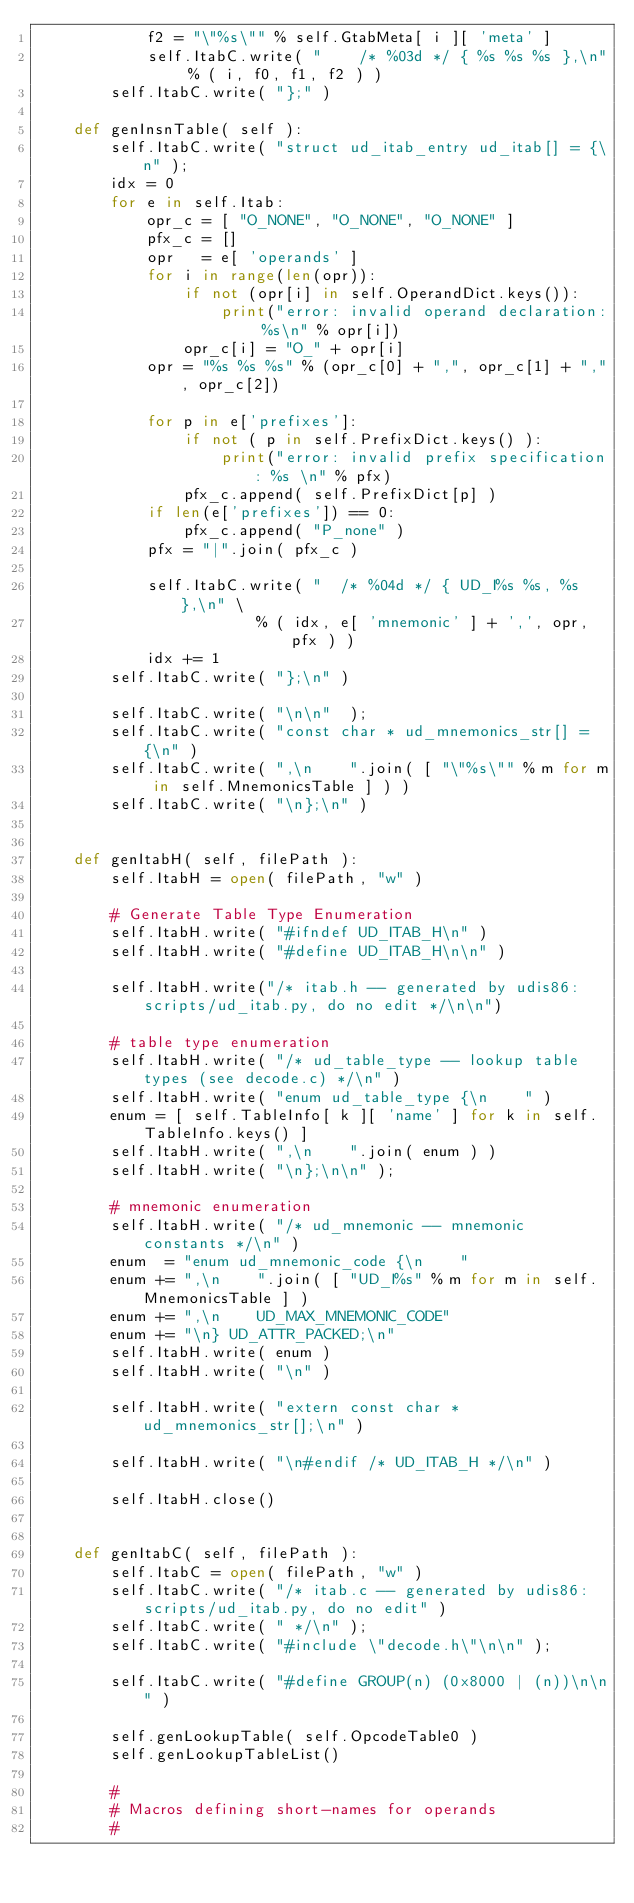<code> <loc_0><loc_0><loc_500><loc_500><_Python_>            f2 = "\"%s\"" % self.GtabMeta[ i ][ 'meta' ]
            self.ItabC.write( "    /* %03d */ { %s %s %s },\n" % ( i, f0, f1, f2 ) )
        self.ItabC.write( "};" )

    def genInsnTable( self ):
        self.ItabC.write( "struct ud_itab_entry ud_itab[] = {\n" );
        idx = 0
        for e in self.Itab:
            opr_c = [ "O_NONE", "O_NONE", "O_NONE" ]
            pfx_c = []
            opr   = e[ 'operands' ]
            for i in range(len(opr)): 
                if not (opr[i] in self.OperandDict.keys()):
                    print("error: invalid operand declaration: %s\n" % opr[i])
                opr_c[i] = "O_" + opr[i]
            opr = "%s %s %s" % (opr_c[0] + ",", opr_c[1] + ",", opr_c[2])

            for p in e['prefixes']:
                if not ( p in self.PrefixDict.keys() ):
                    print("error: invalid prefix specification: %s \n" % pfx)
                pfx_c.append( self.PrefixDict[p] )
            if len(e['prefixes']) == 0:
                pfx_c.append( "P_none" )
            pfx = "|".join( pfx_c )

            self.ItabC.write( "  /* %04d */ { UD_I%s %s, %s },\n" \
                        % ( idx, e[ 'mnemonic' ] + ',', opr, pfx ) )
            idx += 1
        self.ItabC.write( "};\n" )

        self.ItabC.write( "\n\n"  );
        self.ItabC.write( "const char * ud_mnemonics_str[] = {\n" )
        self.ItabC.write( ",\n    ".join( [ "\"%s\"" % m for m in self.MnemonicsTable ] ) )
        self.ItabC.write( "\n};\n" )
 

    def genItabH( self, filePath ):
        self.ItabH = open( filePath, "w" )

        # Generate Table Type Enumeration
        self.ItabH.write( "#ifndef UD_ITAB_H\n" )
        self.ItabH.write( "#define UD_ITAB_H\n\n" )

        self.ItabH.write("/* itab.h -- generated by udis86:scripts/ud_itab.py, do no edit */\n\n")

        # table type enumeration
        self.ItabH.write( "/* ud_table_type -- lookup table types (see decode.c) */\n" )
        self.ItabH.write( "enum ud_table_type {\n    " )
        enum = [ self.TableInfo[ k ][ 'name' ] for k in self.TableInfo.keys() ]
        self.ItabH.write( ",\n    ".join( enum ) )
        self.ItabH.write( "\n};\n\n" );

        # mnemonic enumeration
        self.ItabH.write( "/* ud_mnemonic -- mnemonic constants */\n" )
        enum  = "enum ud_mnemonic_code {\n    "
        enum += ",\n    ".join( [ "UD_I%s" % m for m in self.MnemonicsTable ] )
        enum += ",\n    UD_MAX_MNEMONIC_CODE"
        enum += "\n} UD_ATTR_PACKED;\n"
        self.ItabH.write( enum )
        self.ItabH.write( "\n" )

        self.ItabH.write( "extern const char * ud_mnemonics_str[];\n" )

        self.ItabH.write( "\n#endif /* UD_ITAB_H */\n" )
    
        self.ItabH.close()


    def genItabC( self, filePath ):
        self.ItabC = open( filePath, "w" )
        self.ItabC.write( "/* itab.c -- generated by udis86:scripts/ud_itab.py, do no edit" )
        self.ItabC.write( " */\n" );
        self.ItabC.write( "#include \"decode.h\"\n\n" );

        self.ItabC.write( "#define GROUP(n) (0x8000 | (n))\n\n" )

        self.genLookupTable( self.OpcodeTable0 ) 
        self.genLookupTableList()

        #
        # Macros defining short-names for operands
        #</code> 